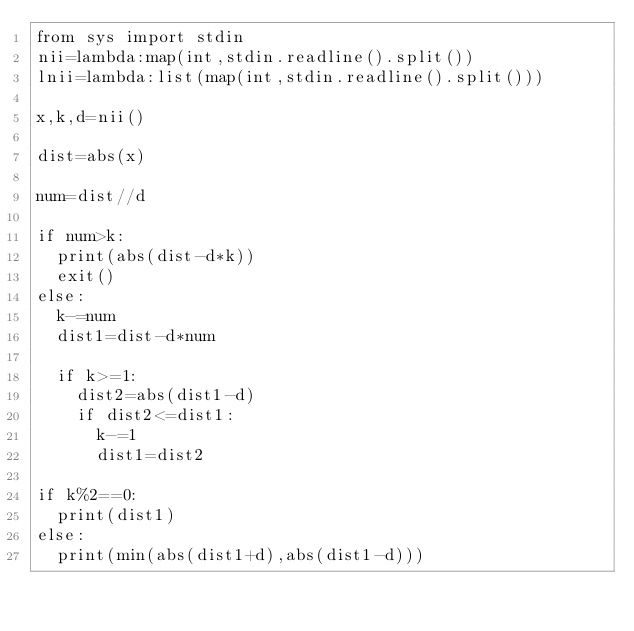Convert code to text. <code><loc_0><loc_0><loc_500><loc_500><_Python_>from sys import stdin
nii=lambda:map(int,stdin.readline().split())
lnii=lambda:list(map(int,stdin.readline().split()))

x,k,d=nii()

dist=abs(x)

num=dist//d

if num>k:
  print(abs(dist-d*k))
  exit()
else:
  k-=num
  dist1=dist-d*num

  if k>=1:
    dist2=abs(dist1-d)
    if dist2<=dist1:
      k-=1
      dist1=dist2

if k%2==0:
  print(dist1)
else:
  print(min(abs(dist1+d),abs(dist1-d)))</code> 